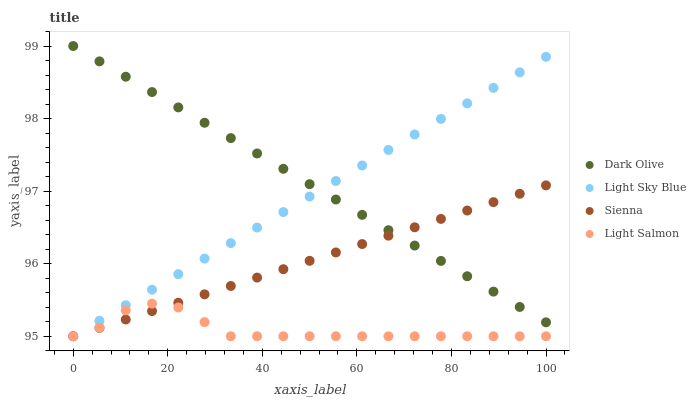Does Light Salmon have the minimum area under the curve?
Answer yes or no. Yes. Does Dark Olive have the maximum area under the curve?
Answer yes or no. Yes. Does Dark Olive have the minimum area under the curve?
Answer yes or no. No. Does Light Salmon have the maximum area under the curve?
Answer yes or no. No. Is Light Sky Blue the smoothest?
Answer yes or no. Yes. Is Light Salmon the roughest?
Answer yes or no. Yes. Is Dark Olive the smoothest?
Answer yes or no. No. Is Dark Olive the roughest?
Answer yes or no. No. Does Sienna have the lowest value?
Answer yes or no. Yes. Does Dark Olive have the lowest value?
Answer yes or no. No. Does Dark Olive have the highest value?
Answer yes or no. Yes. Does Light Salmon have the highest value?
Answer yes or no. No. Is Light Salmon less than Dark Olive?
Answer yes or no. Yes. Is Dark Olive greater than Light Salmon?
Answer yes or no. Yes. Does Sienna intersect Dark Olive?
Answer yes or no. Yes. Is Sienna less than Dark Olive?
Answer yes or no. No. Is Sienna greater than Dark Olive?
Answer yes or no. No. Does Light Salmon intersect Dark Olive?
Answer yes or no. No. 